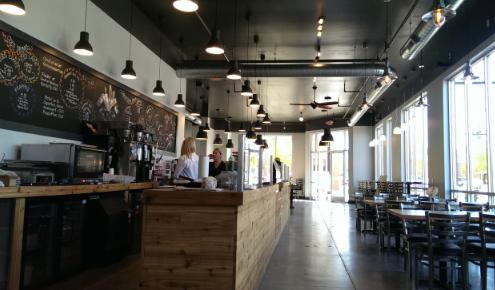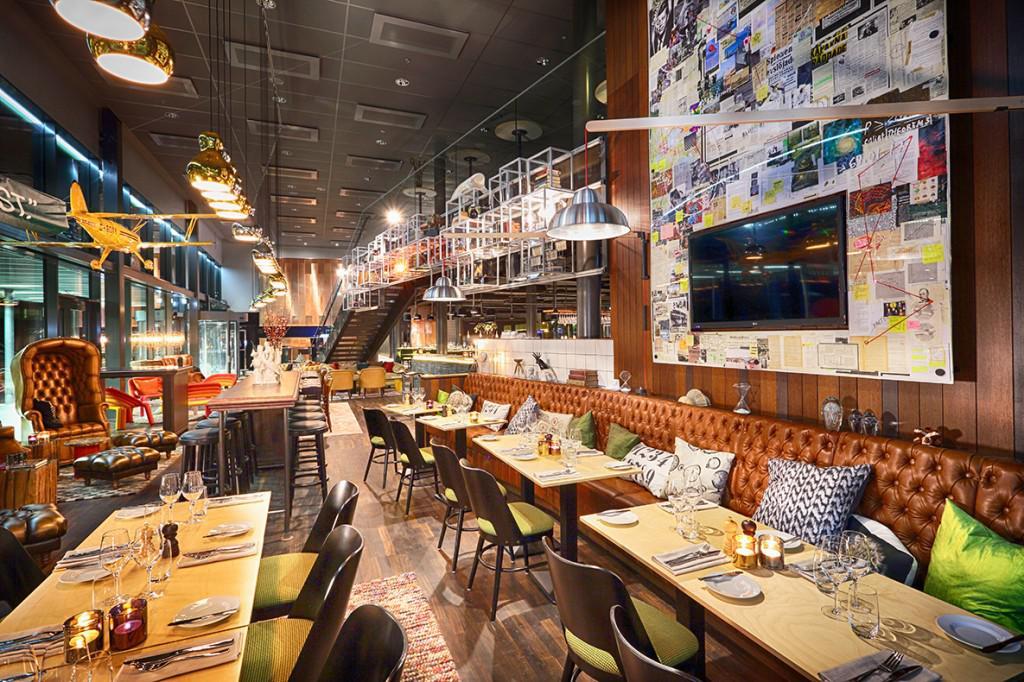The first image is the image on the left, the second image is the image on the right. For the images displayed, is the sentence "The tables in the right image are long bench style tables." factually correct? Answer yes or no. Yes. The first image is the image on the left, the second image is the image on the right. Assess this claim about the two images: "There is at least four white cloth tables.". Correct or not? Answer yes or no. No. 